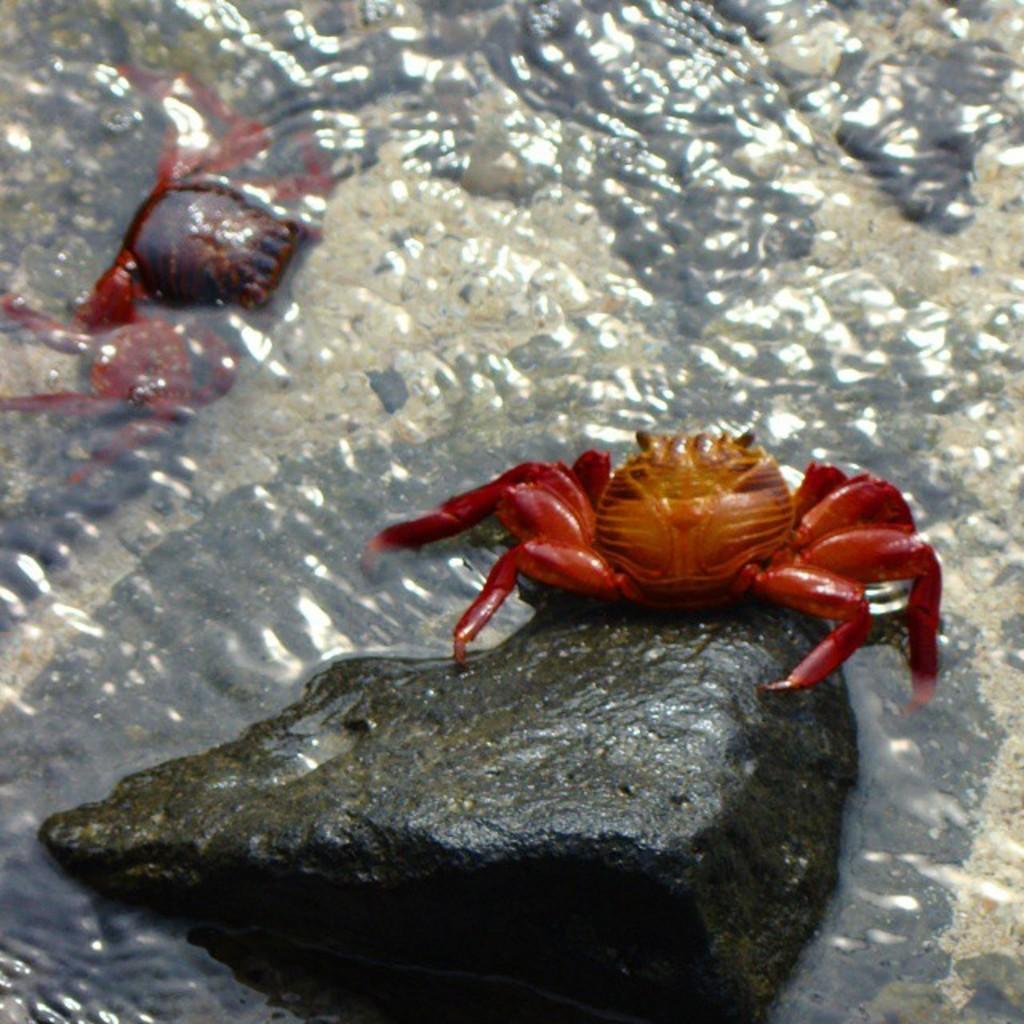Could you give a brief overview of what you see in this image? In this image we can see crabs and stone in the water. 